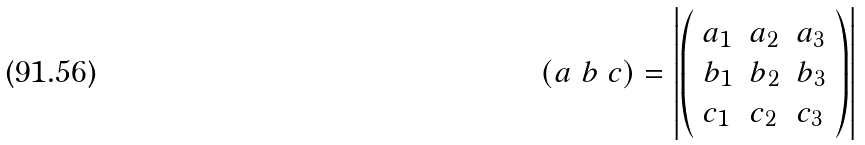Convert formula to latex. <formula><loc_0><loc_0><loc_500><loc_500>( a \ b \ c ) = \left | { \left ( \begin{array} { l l l } { a _ { 1 } } & { a _ { 2 } } & { a _ { 3 } } \\ { b _ { 1 } } & { b _ { 2 } } & { b _ { 3 } } \\ { c _ { 1 } } & { c _ { 2 } } & { c _ { 3 } } \end{array} \right ) } \right |</formula> 